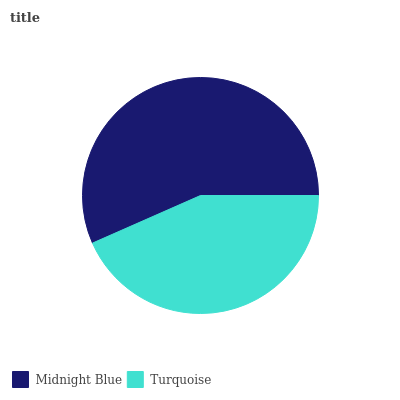Is Turquoise the minimum?
Answer yes or no. Yes. Is Midnight Blue the maximum?
Answer yes or no. Yes. Is Turquoise the maximum?
Answer yes or no. No. Is Midnight Blue greater than Turquoise?
Answer yes or no. Yes. Is Turquoise less than Midnight Blue?
Answer yes or no. Yes. Is Turquoise greater than Midnight Blue?
Answer yes or no. No. Is Midnight Blue less than Turquoise?
Answer yes or no. No. Is Midnight Blue the high median?
Answer yes or no. Yes. Is Turquoise the low median?
Answer yes or no. Yes. Is Turquoise the high median?
Answer yes or no. No. Is Midnight Blue the low median?
Answer yes or no. No. 